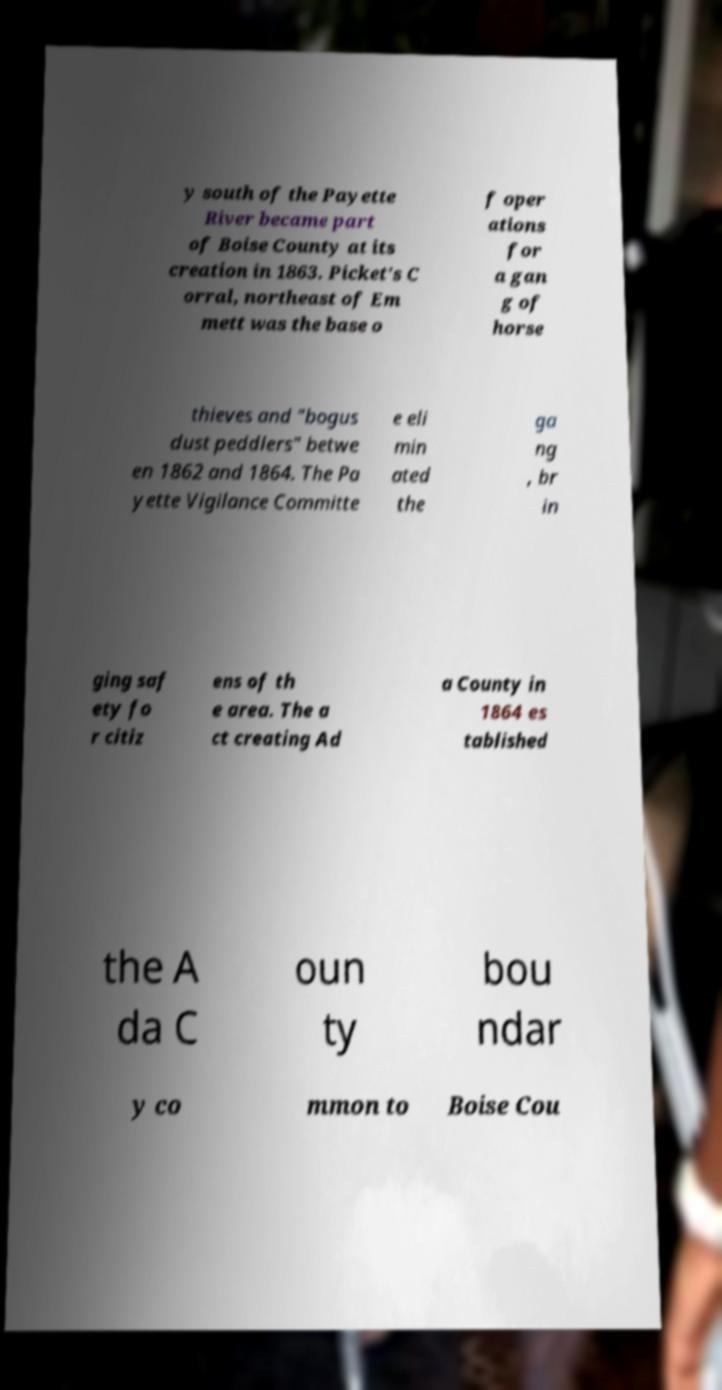For documentation purposes, I need the text within this image transcribed. Could you provide that? y south of the Payette River became part of Boise County at its creation in 1863. Picket's C orral, northeast of Em mett was the base o f oper ations for a gan g of horse thieves and "bogus dust peddlers" betwe en 1862 and 1864. The Pa yette Vigilance Committe e eli min ated the ga ng , br in ging saf ety fo r citiz ens of th e area. The a ct creating Ad a County in 1864 es tablished the A da C oun ty bou ndar y co mmon to Boise Cou 